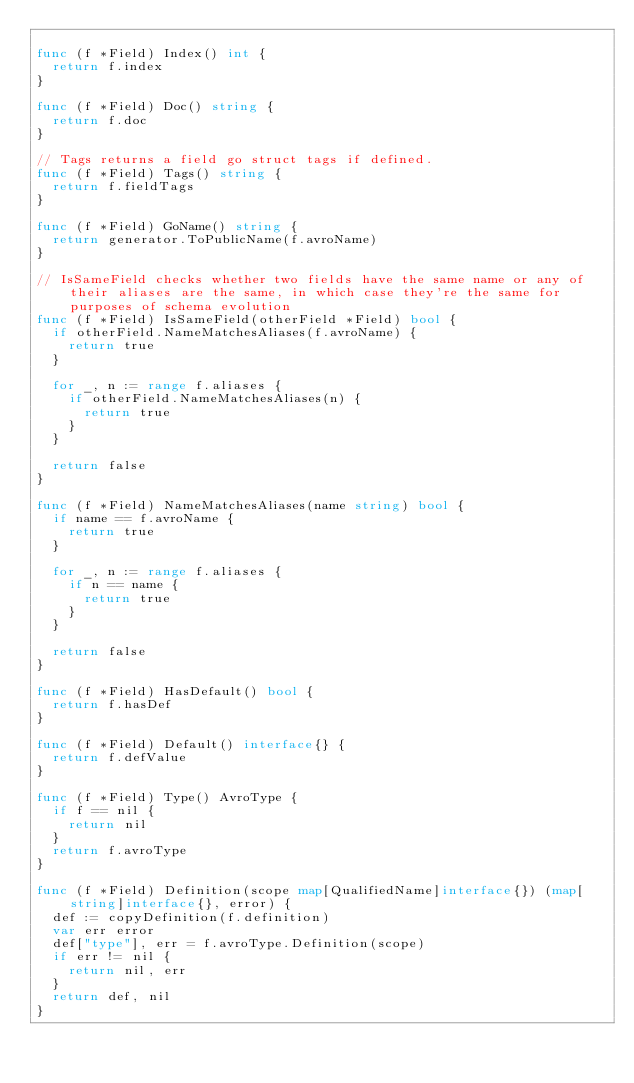<code> <loc_0><loc_0><loc_500><loc_500><_Go_>
func (f *Field) Index() int {
	return f.index
}

func (f *Field) Doc() string {
	return f.doc
}

// Tags returns a field go struct tags if defined.
func (f *Field) Tags() string {
	return f.fieldTags
}

func (f *Field) GoName() string {
	return generator.ToPublicName(f.avroName)
}

// IsSameField checks whether two fields have the same name or any of their aliases are the same, in which case they're the same for purposes of schema evolution
func (f *Field) IsSameField(otherField *Field) bool {
	if otherField.NameMatchesAliases(f.avroName) {
		return true
	}

	for _, n := range f.aliases {
		if otherField.NameMatchesAliases(n) {
			return true
		}
	}

	return false
}

func (f *Field) NameMatchesAliases(name string) bool {
	if name == f.avroName {
		return true
	}

	for _, n := range f.aliases {
		if n == name {
			return true
		}
	}

	return false
}

func (f *Field) HasDefault() bool {
	return f.hasDef
}

func (f *Field) Default() interface{} {
	return f.defValue
}

func (f *Field) Type() AvroType {
	if f == nil {
		return nil
	}
	return f.avroType
}

func (f *Field) Definition(scope map[QualifiedName]interface{}) (map[string]interface{}, error) {
	def := copyDefinition(f.definition)
	var err error
	def["type"], err = f.avroType.Definition(scope)
	if err != nil {
		return nil, err
	}
	return def, nil
}
</code> 